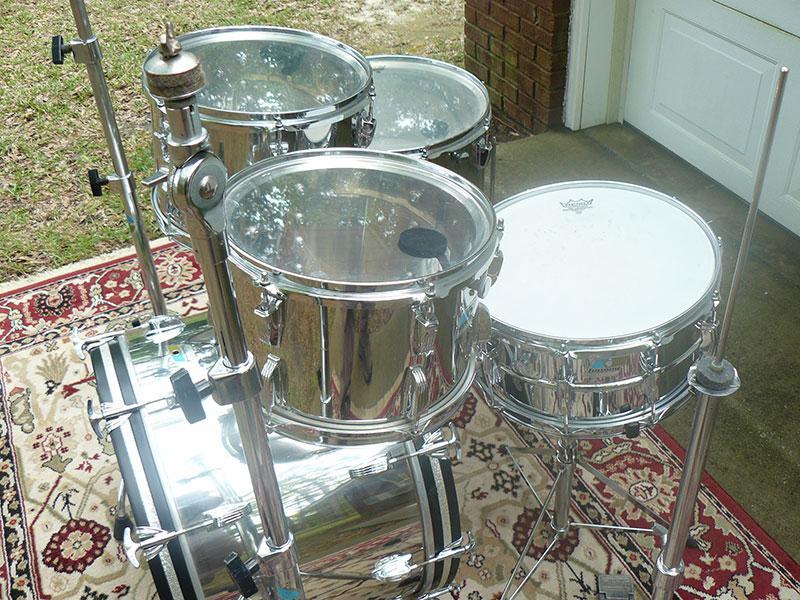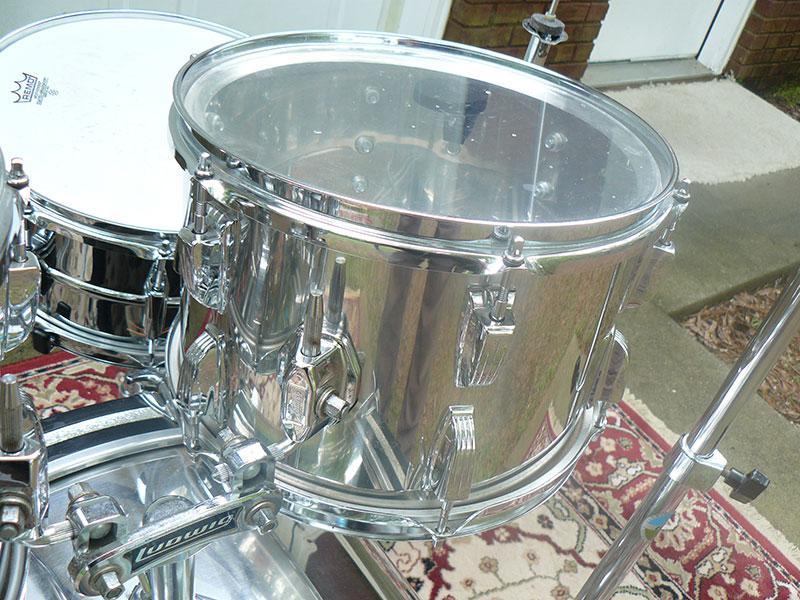The first image is the image on the left, the second image is the image on the right. For the images displayed, is the sentence "The drum set on the left includes cymbals." factually correct? Answer yes or no. No. The first image is the image on the left, the second image is the image on the right. Examine the images to the left and right. Is the description "There are three kick drums." accurate? Answer yes or no. No. 